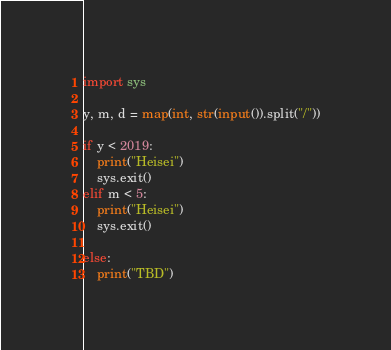<code> <loc_0><loc_0><loc_500><loc_500><_Python_>import sys

y, m, d = map(int, str(input()).split("/"))

if y < 2019:
    print("Heisei")
    sys.exit()
elif m < 5:
    print("Heisei")
    sys.exit()

else:
    print("TBD")
</code> 